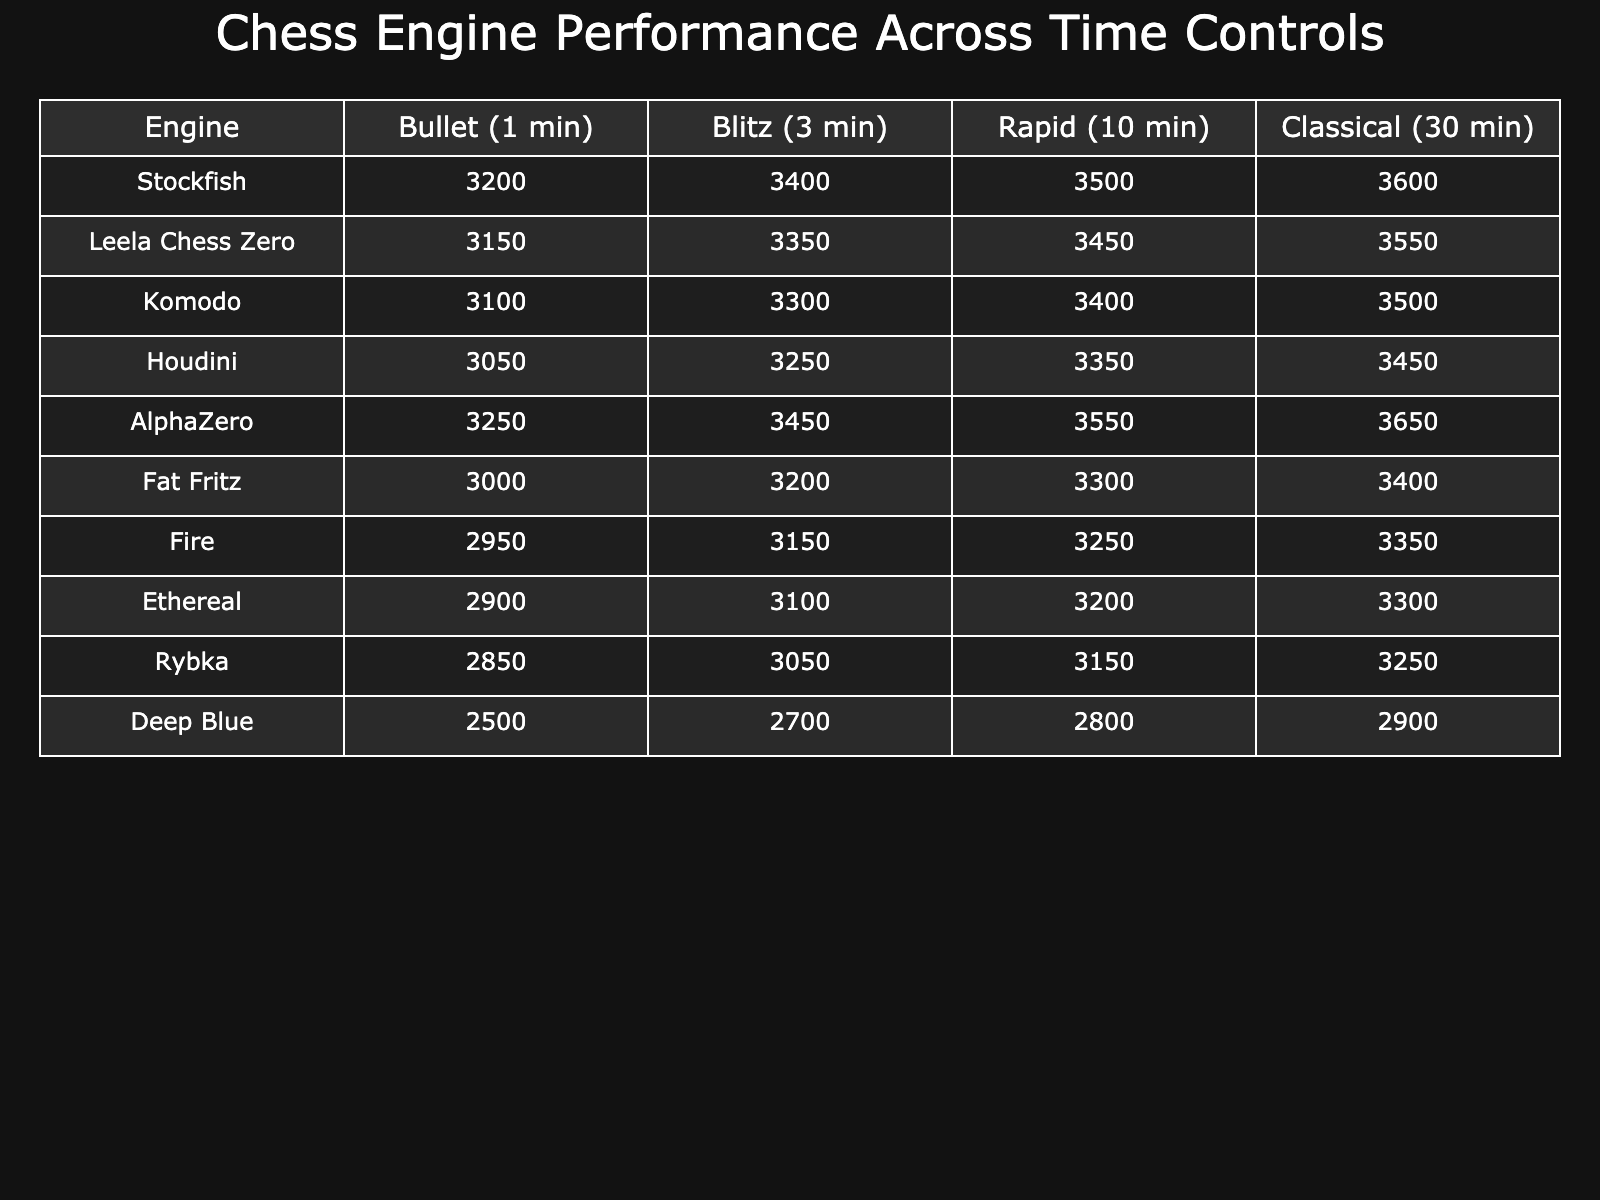What is the highest performance score in the Bullet category? Looking at the Bullet category's scores, Stockfish has the highest value at 3200.
Answer: 3200 Which chess engine has the lowest performance score in the Classical category? In the Classical category, Deep Blue has the lowest score at 2900, which is lower than all the other engines listed.
Answer: 2900 What is the average performance score for Leela Chess Zero across all time controls? The scores for Leela Chess Zero are 3150, 3350, 3450, and 3550. Adding these gives 3150 + 3350 + 3450 + 3550 = 13500. Dividing by the 4 categories, 13500 / 4 = 3375.
Answer: 3375 Is it true that AlphaZero performs better than Stockfish in all time controls? Comparing the scores in each category, AlphaZero outperforms Stockfish in Bullet and Blitz but is outperformed by Stockfish in Rapid and Classical. So, it is false.
Answer: False What is the difference in performance score between the highest and lowest performing engines in the Blitz category? The highest score in the Blitz category is Stockfish with 3400 and the lowest is Deep Blue with 2700. The difference is 3400 - 2700 = 700.
Answer: 700 What is the total performance score of Ethereal across all time controls? Ethereal's scores are 2900, 3100, 3200, and 3300. Summing these gives 2900 + 3100 + 3200 + 3300 = 12500.
Answer: 12500 Which two engines have the closest performance scores in the Rapid category? Looking at the Rapid scores, Komodo at 3400 and Houdini at 3350 have a difference of only 50, which is the smallest among the competitors.
Answer: Komodo and Houdini What is the average performance score across all engines for the Bullet category? The Bullet scores are 3200, 3150, 3100, 3050, 3250, 3000, 2950, 2900, 2850, and 2500. Summing them gives 3200 + 3150 + 3100 + 3050 + 3250 + 3000 + 2950 + 2900 + 2850 + 2500 = 29500. Dividing by 10 gives 29500 / 10 = 2950.
Answer: 2950 Which chess engine improved its score the most from Blitz to Classical? Comparing the Blitz and Classical scores for each engine, AlphaZero's score improves from 3450 in Blitz to 3650 in Classical, a gain of 200. No other engine has as large of an improvement.
Answer: AlphaZero What is the median performance score of Deep Blue across all time controls? The scores for Deep Blue are 2500, 2700, 2800, and 2900. Out of four numbers, the median is the average of the two middle values (2700 and 2800), which is (2700 + 2800) / 2 = 2750.
Answer: 2750 